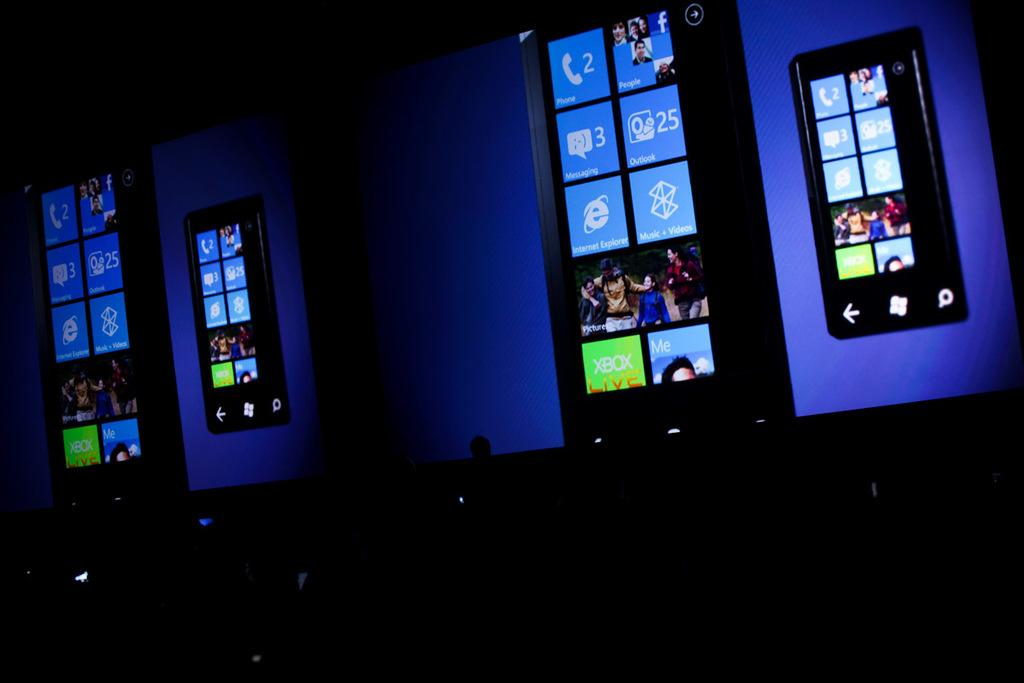What is the overall lighting condition in the image? The image is dark. What objects are present in the image? There are screens in the image. What color light is present in the background of the image? The background has a blue color light. Can you see the arm of the person in the image? There is no person present in the image, so it is not possible to see their arm. 